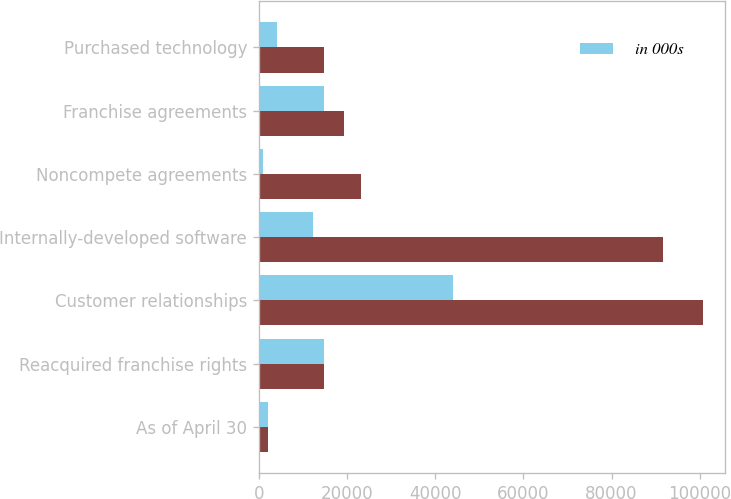Convert chart to OTSL. <chart><loc_0><loc_0><loc_500><loc_500><stacked_bar_chart><ecel><fcel>As of April 30<fcel>Reacquired franchise rights<fcel>Customer relationships<fcel>Internally-developed software<fcel>Noncompete agreements<fcel>Franchise agreements<fcel>Purchased technology<nl><fcel>nan<fcel>2013<fcel>14814<fcel>100719<fcel>91745<fcel>23058<fcel>19201<fcel>14800<nl><fcel>in 000s<fcel>2012<fcel>14814<fcel>43929<fcel>12213<fcel>912<fcel>14828<fcel>4035<nl></chart> 